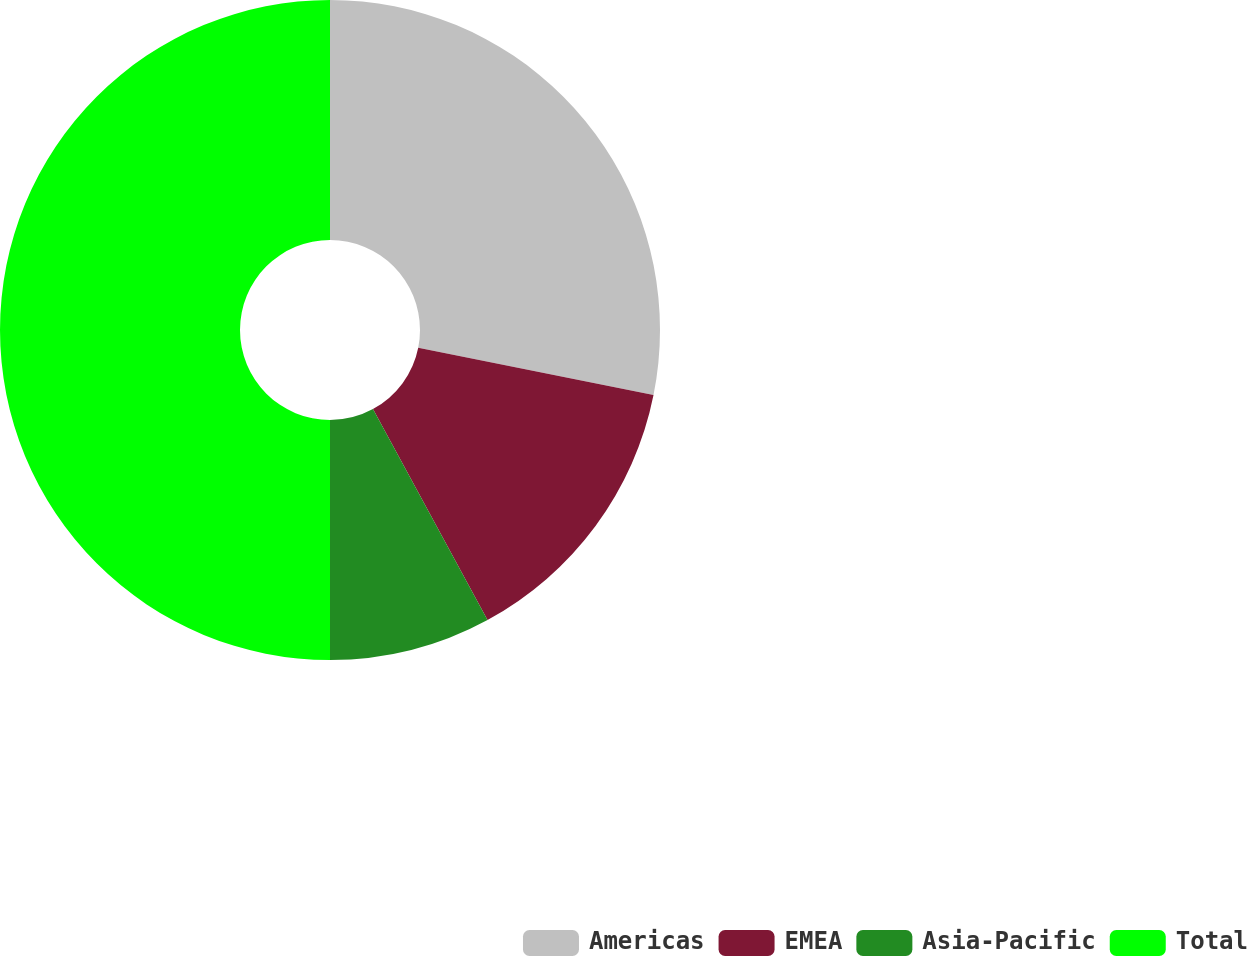Convert chart to OTSL. <chart><loc_0><loc_0><loc_500><loc_500><pie_chart><fcel>Americas<fcel>EMEA<fcel>Asia-Pacific<fcel>Total<nl><fcel>28.16%<fcel>13.92%<fcel>7.92%<fcel>50.0%<nl></chart> 